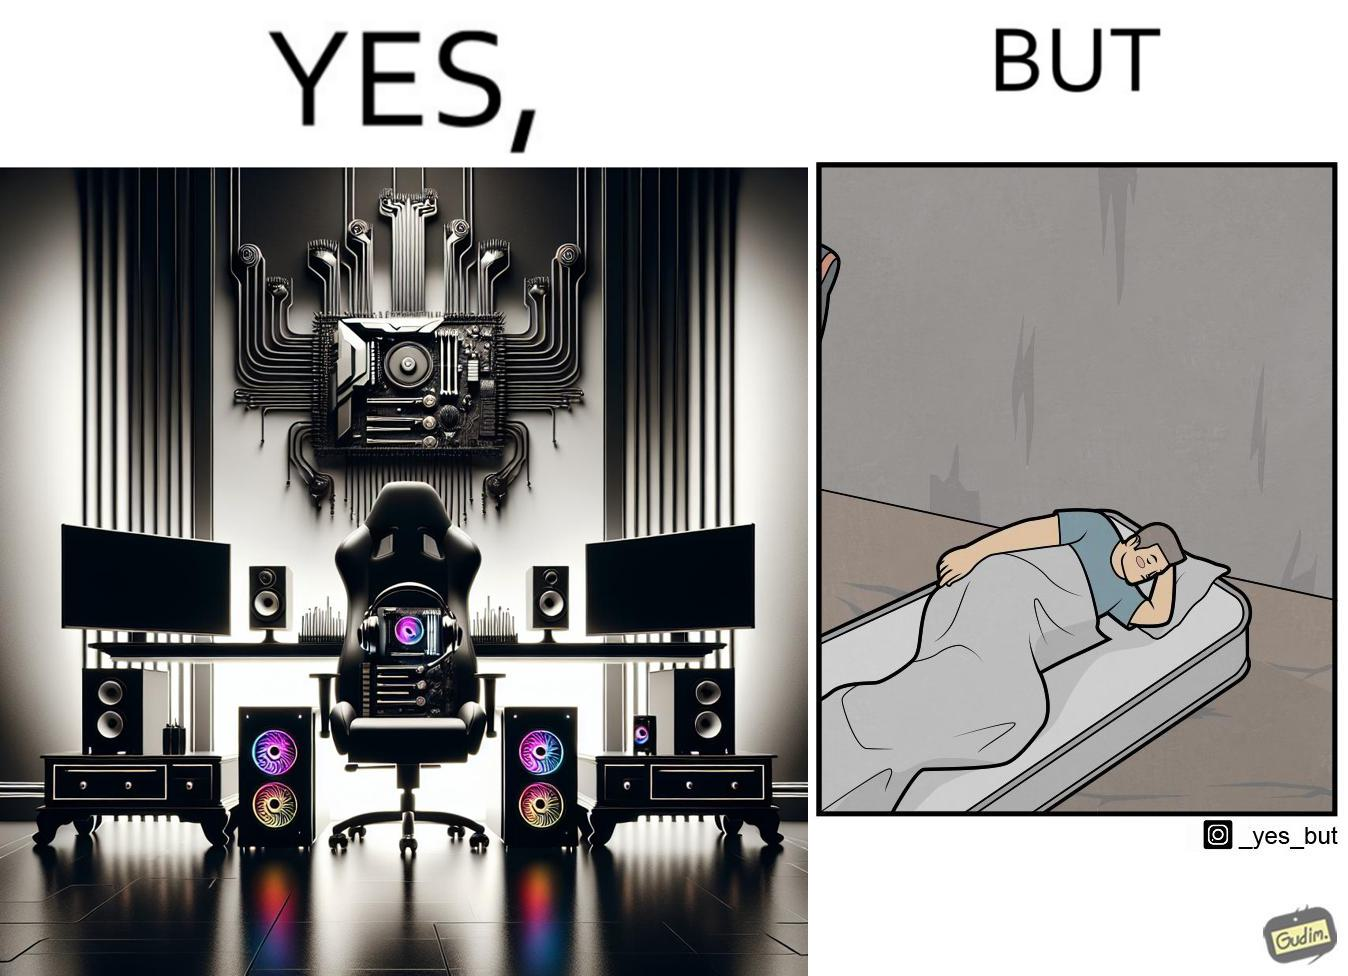Would you classify this image as satirical? Yes, this image is satirical. 